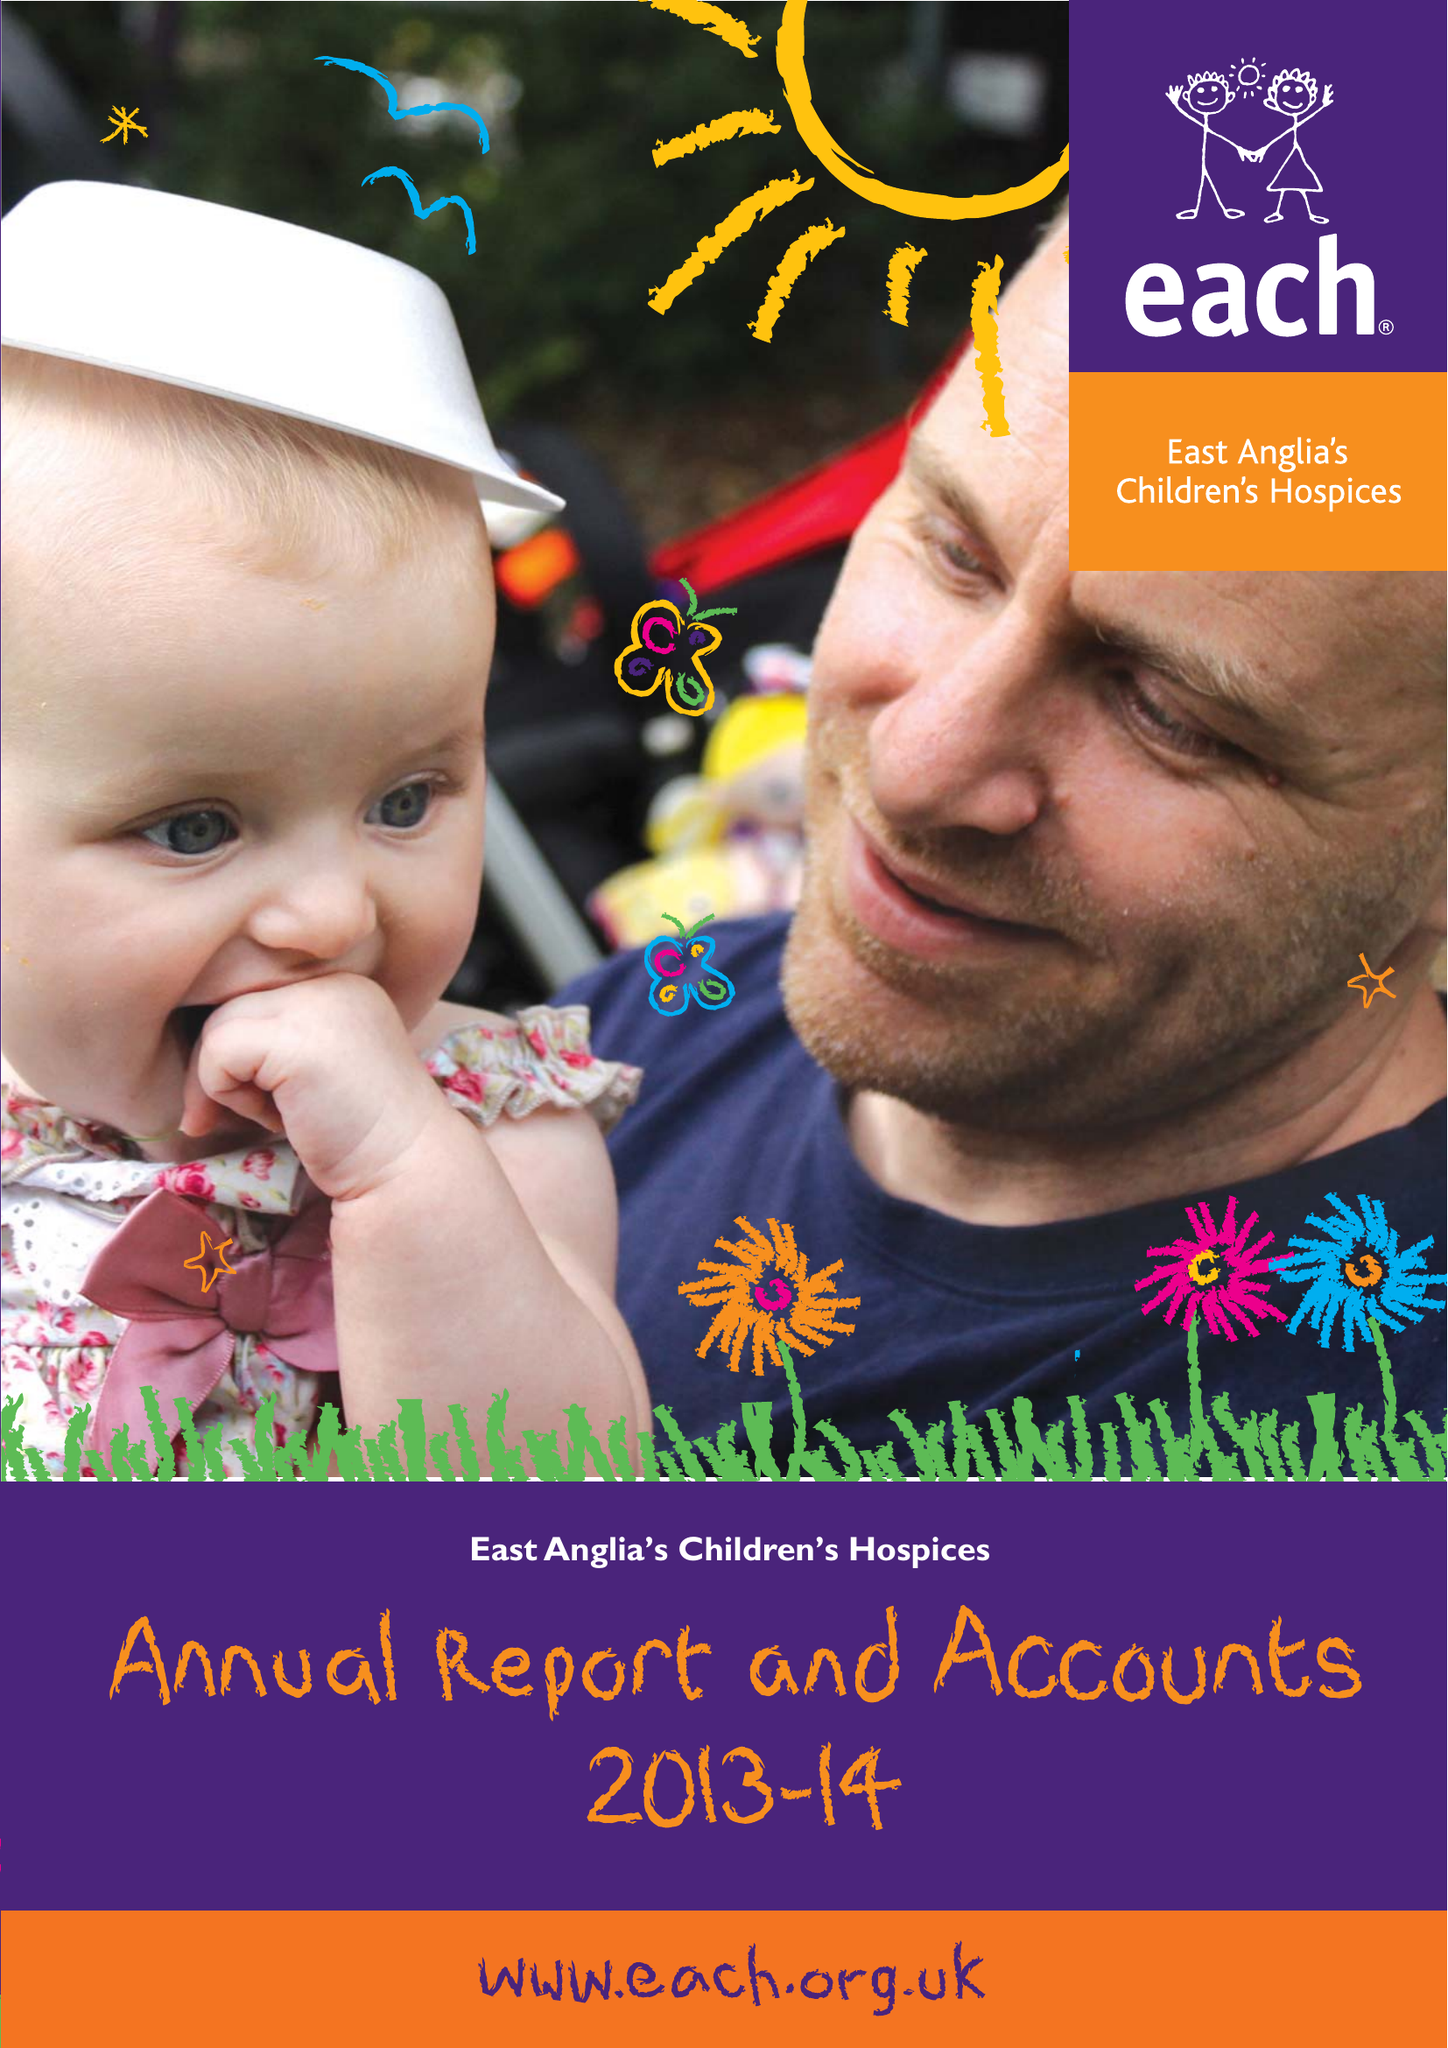What is the value for the charity_name?
Answer the question using a single word or phrase. East Anglia's Children's Hospices 